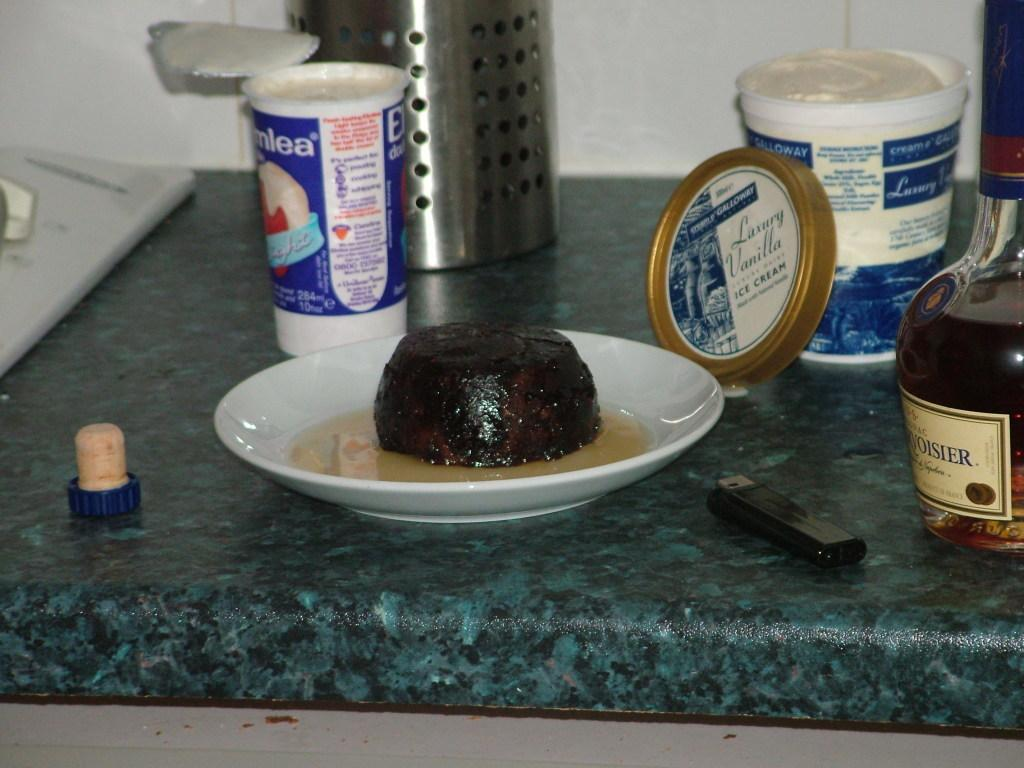Provide a one-sentence caption for the provided image. On a counter, amongst other food products, is an open container of luxury vanilla ice cream. 